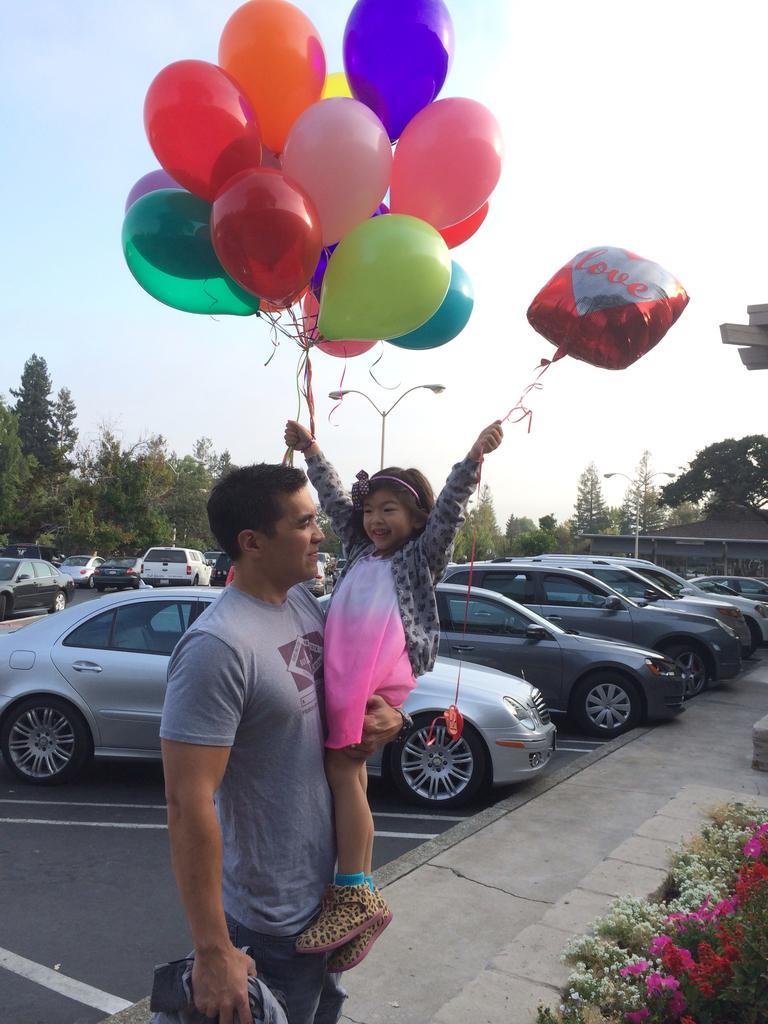In one or two sentences, can you explain what this image depicts? In this image I can see two people with different color dresses. I can see one person holding the colorful balloons and an another person holding the cloth. To the right I can see the pink, red and white color flowers to the plants. In the background I can see many vehicles on the road. I can also see the pole, building, many trees and the sky. 